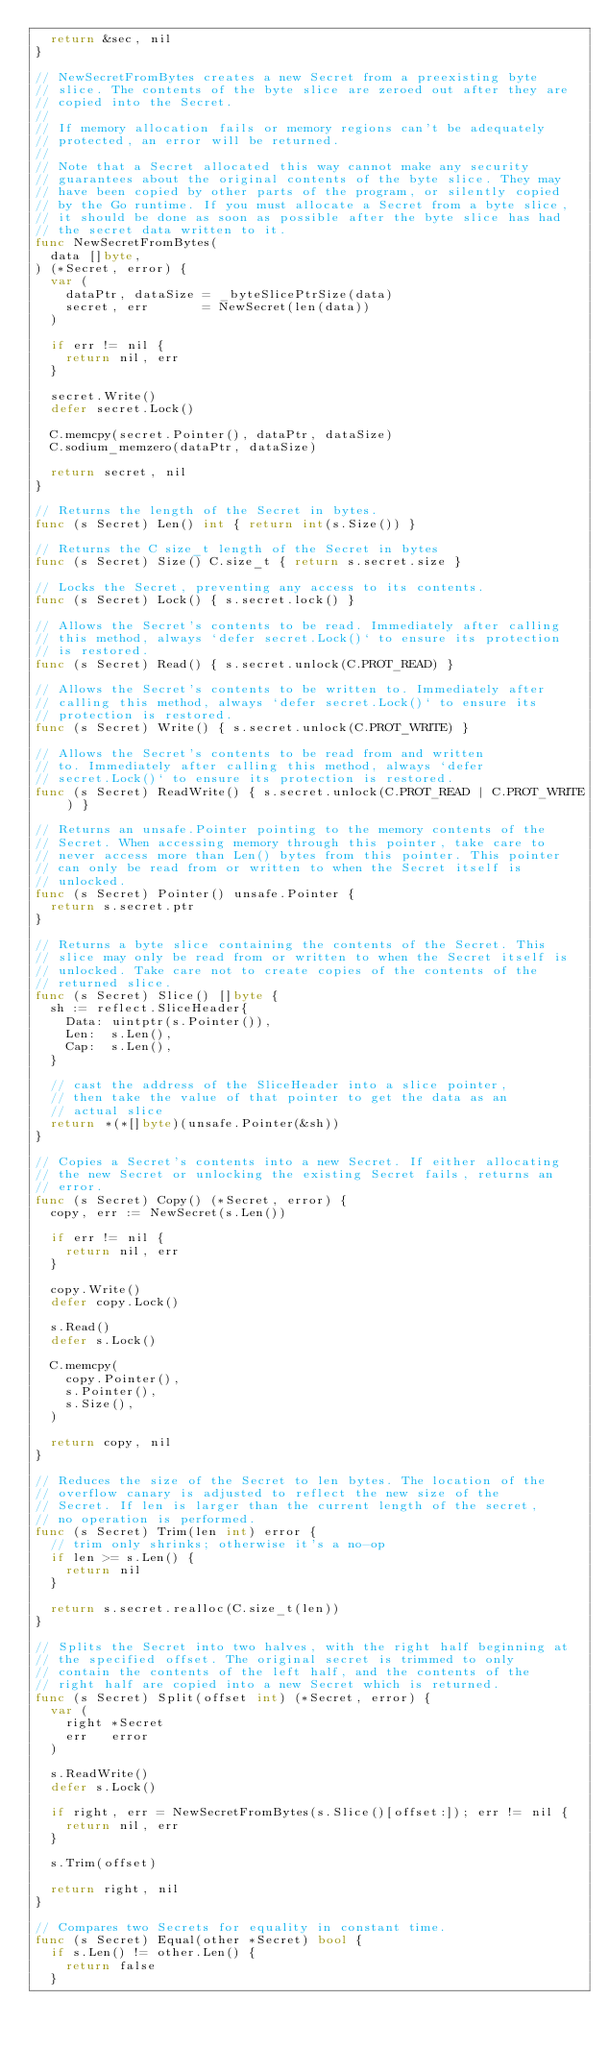Convert code to text. <code><loc_0><loc_0><loc_500><loc_500><_Go_>	return &sec, nil
}

// NewSecretFromBytes creates a new Secret from a preexisting byte
// slice. The contents of the byte slice are zeroed out after they are
// copied into the Secret.
//
// If memory allocation fails or memory regions can't be adequately
// protected, an error will be returned.
//
// Note that a Secret allocated this way cannot make any security
// guarantees about the original contents of the byte slice. They may
// have been copied by other parts of the program, or silently copied
// by the Go runtime. If you must allocate a Secret from a byte slice,
// it should be done as soon as possible after the byte slice has had
// the secret data written to it.
func NewSecretFromBytes(
	data []byte,
) (*Secret, error) {
	var (
		dataPtr, dataSize = _byteSlicePtrSize(data)
		secret, err       = NewSecret(len(data))
	)

	if err != nil {
		return nil, err
	}

	secret.Write()
	defer secret.Lock()

	C.memcpy(secret.Pointer(), dataPtr, dataSize)
	C.sodium_memzero(dataPtr, dataSize)

	return secret, nil
}

// Returns the length of the Secret in bytes.
func (s Secret) Len() int { return int(s.Size()) }

// Returns the C size_t length of the Secret in bytes
func (s Secret) Size() C.size_t { return s.secret.size }

// Locks the Secret, preventing any access to its contents.
func (s Secret) Lock() { s.secret.lock() }

// Allows the Secret's contents to be read. Immediately after calling
// this method, always `defer secret.Lock()` to ensure its protection
// is restored.
func (s Secret) Read() { s.secret.unlock(C.PROT_READ) }

// Allows the Secret's contents to be written to. Immediately after
// calling this method, always `defer secret.Lock()` to ensure its
// protection is restored.
func (s Secret) Write() { s.secret.unlock(C.PROT_WRITE) }

// Allows the Secret's contents to be read from and written
// to. Immediately after calling this method, always `defer
// secret.Lock()` to ensure its protection is restored.
func (s Secret) ReadWrite() { s.secret.unlock(C.PROT_READ | C.PROT_WRITE) }

// Returns an unsafe.Pointer pointing to the memory contents of the
// Secret. When accessing memory through this pointer, take care to
// never access more than Len() bytes from this pointer. This pointer
// can only be read from or written to when the Secret itself is
// unlocked.
func (s Secret) Pointer() unsafe.Pointer {
	return s.secret.ptr
}

// Returns a byte slice containing the contents of the Secret. This
// slice may only be read from or written to when the Secret itself is
// unlocked. Take care not to create copies of the contents of the
// returned slice.
func (s Secret) Slice() []byte {
	sh := reflect.SliceHeader{
		Data: uintptr(s.Pointer()),
		Len:  s.Len(),
		Cap:  s.Len(),
	}

	// cast the address of the SliceHeader into a slice pointer,
	// then take the value of that pointer to get the data as an
	// actual slice
	return *(*[]byte)(unsafe.Pointer(&sh))
}

// Copies a Secret's contents into a new Secret. If either allocating
// the new Secret or unlocking the existing Secret fails, returns an
// error.
func (s Secret) Copy() (*Secret, error) {
	copy, err := NewSecret(s.Len())

	if err != nil {
		return nil, err
	}

	copy.Write()
	defer copy.Lock()

	s.Read()
	defer s.Lock()

	C.memcpy(
		copy.Pointer(),
		s.Pointer(),
		s.Size(),
	)

	return copy, nil
}

// Reduces the size of the Secret to len bytes. The location of the
// overflow canary is adjusted to reflect the new size of the
// Secret. If len is larger than the current length of the secret,
// no operation is performed.
func (s Secret) Trim(len int) error {
	// trim only shrinks; otherwise it's a no-op
	if len >= s.Len() {
		return nil
	}

	return s.secret.realloc(C.size_t(len))
}

// Splits the Secret into two halves, with the right half beginning at
// the specified offset. The original secret is trimmed to only
// contain the contents of the left half, and the contents of the
// right half are copied into a new Secret which is returned.
func (s Secret) Split(offset int) (*Secret, error) {
	var (
		right *Secret
		err   error
	)

	s.ReadWrite()
	defer s.Lock()

	if right, err = NewSecretFromBytes(s.Slice()[offset:]); err != nil {
		return nil, err
	}

	s.Trim(offset)

	return right, nil
}

// Compares two Secrets for equality in constant time.
func (s Secret) Equal(other *Secret) bool {
	if s.Len() != other.Len() {
		return false
	}
</code> 